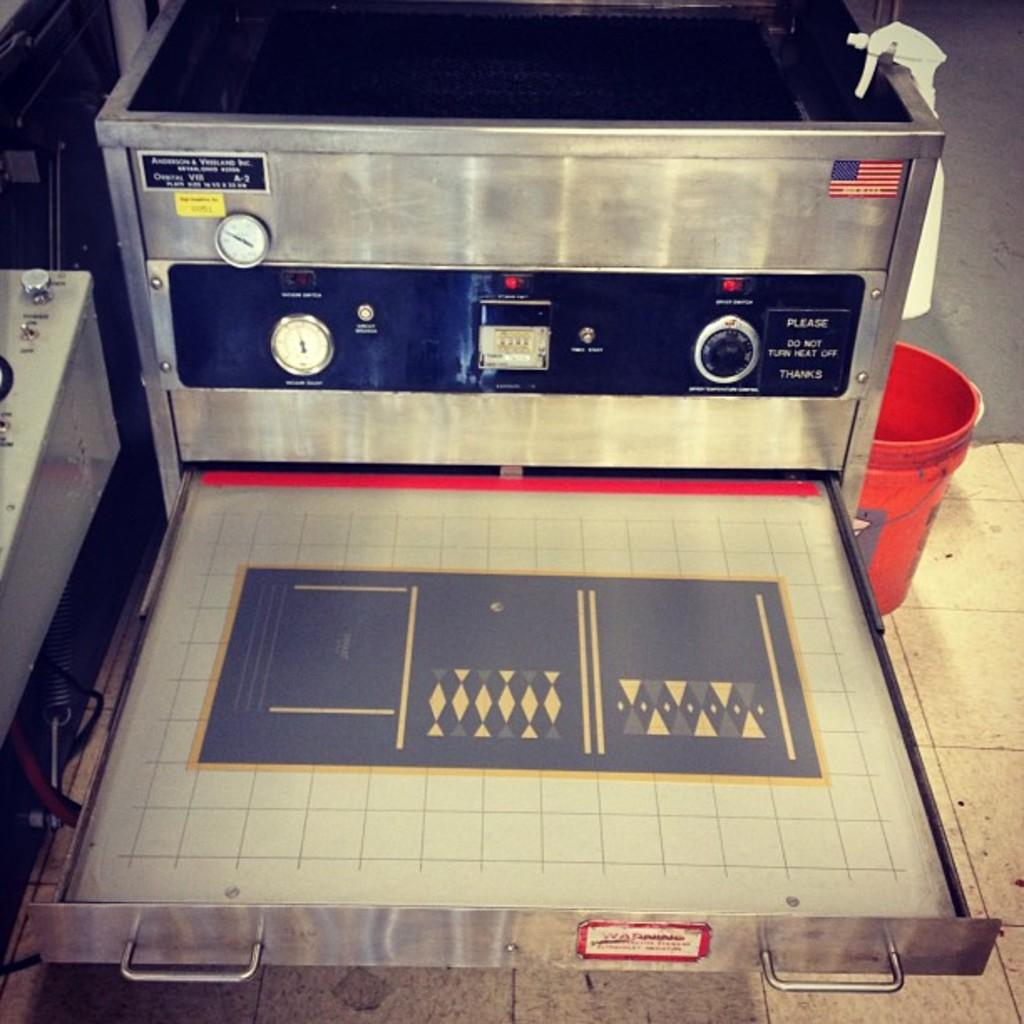<image>
Present a compact description of the photo's key features. A machine that has a sticker reading please do not turn heat off. 